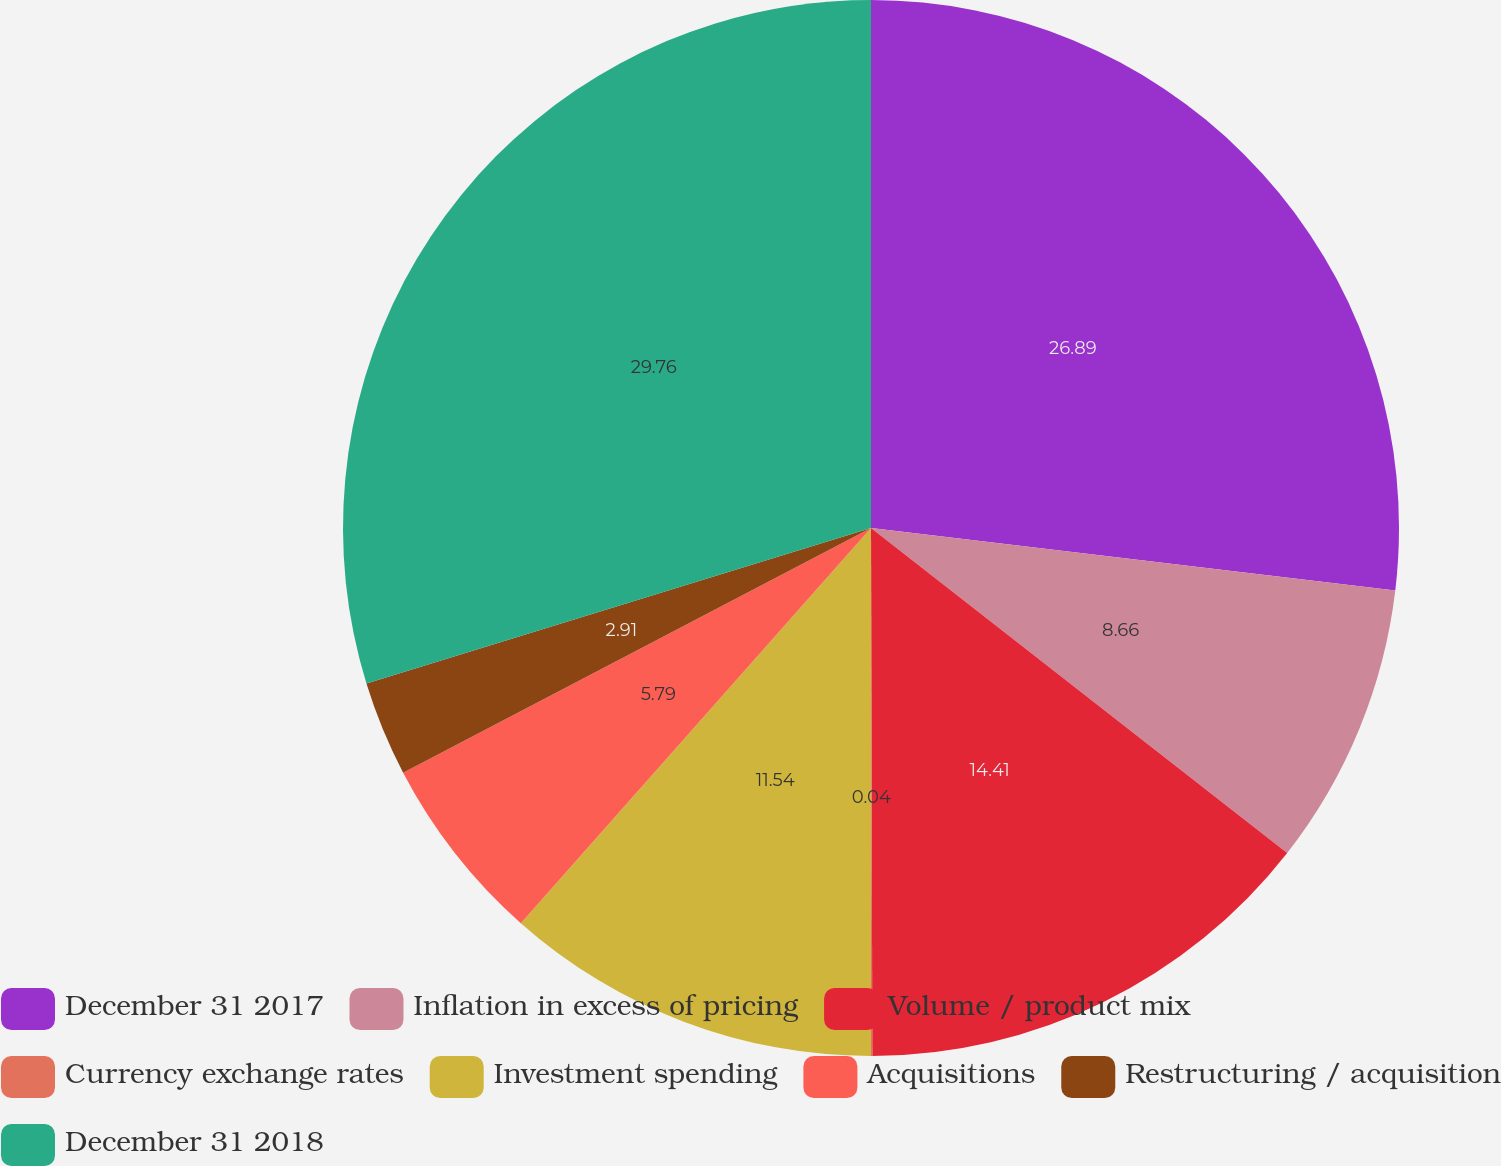Convert chart. <chart><loc_0><loc_0><loc_500><loc_500><pie_chart><fcel>December 31 2017<fcel>Inflation in excess of pricing<fcel>Volume / product mix<fcel>Currency exchange rates<fcel>Investment spending<fcel>Acquisitions<fcel>Restructuring / acquisition<fcel>December 31 2018<nl><fcel>26.89%<fcel>8.66%<fcel>14.41%<fcel>0.04%<fcel>11.54%<fcel>5.79%<fcel>2.91%<fcel>29.76%<nl></chart> 